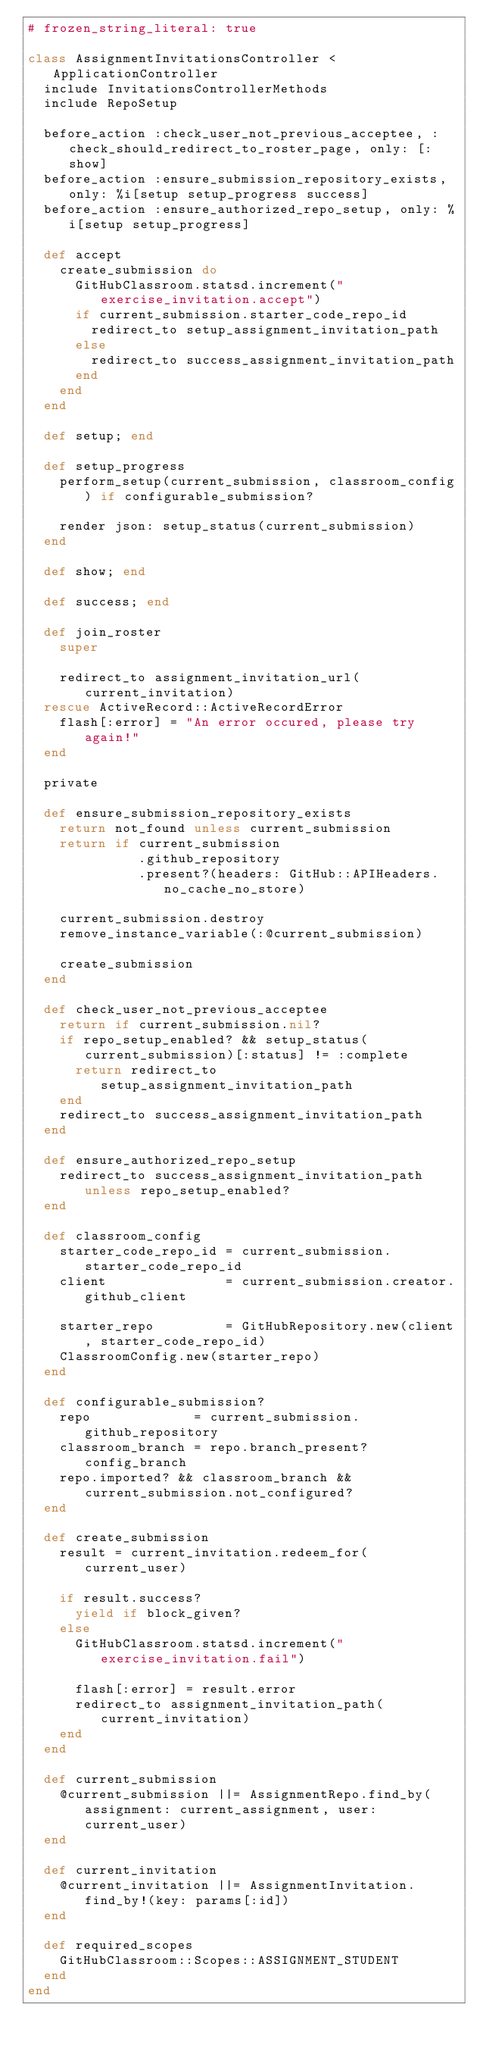Convert code to text. <code><loc_0><loc_0><loc_500><loc_500><_Ruby_># frozen_string_literal: true

class AssignmentInvitationsController < ApplicationController
  include InvitationsControllerMethods
  include RepoSetup

  before_action :check_user_not_previous_acceptee, :check_should_redirect_to_roster_page, only: [:show]
  before_action :ensure_submission_repository_exists, only: %i[setup setup_progress success]
  before_action :ensure_authorized_repo_setup, only: %i[setup setup_progress]

  def accept
    create_submission do
      GitHubClassroom.statsd.increment("exercise_invitation.accept")
      if current_submission.starter_code_repo_id
        redirect_to setup_assignment_invitation_path
      else
        redirect_to success_assignment_invitation_path
      end
    end
  end

  def setup; end

  def setup_progress
    perform_setup(current_submission, classroom_config) if configurable_submission?

    render json: setup_status(current_submission)
  end

  def show; end

  def success; end

  def join_roster
    super

    redirect_to assignment_invitation_url(current_invitation)
  rescue ActiveRecord::ActiveRecordError
    flash[:error] = "An error occured, please try again!"
  end

  private

  def ensure_submission_repository_exists
    return not_found unless current_submission
    return if current_submission
              .github_repository
              .present?(headers: GitHub::APIHeaders.no_cache_no_store)

    current_submission.destroy
    remove_instance_variable(:@current_submission)

    create_submission
  end

  def check_user_not_previous_acceptee
    return if current_submission.nil?
    if repo_setup_enabled? && setup_status(current_submission)[:status] != :complete
      return redirect_to setup_assignment_invitation_path
    end
    redirect_to success_assignment_invitation_path
  end

  def ensure_authorized_repo_setup
    redirect_to success_assignment_invitation_path unless repo_setup_enabled?
  end

  def classroom_config
    starter_code_repo_id = current_submission.starter_code_repo_id
    client               = current_submission.creator.github_client

    starter_repo         = GitHubRepository.new(client, starter_code_repo_id)
    ClassroomConfig.new(starter_repo)
  end

  def configurable_submission?
    repo             = current_submission.github_repository
    classroom_branch = repo.branch_present? config_branch
    repo.imported? && classroom_branch && current_submission.not_configured?
  end

  def create_submission
    result = current_invitation.redeem_for(current_user)

    if result.success?
      yield if block_given?
    else
      GitHubClassroom.statsd.increment("exercise_invitation.fail")

      flash[:error] = result.error
      redirect_to assignment_invitation_path(current_invitation)
    end
  end

  def current_submission
    @current_submission ||= AssignmentRepo.find_by(assignment: current_assignment, user: current_user)
  end

  def current_invitation
    @current_invitation ||= AssignmentInvitation.find_by!(key: params[:id])
  end

  def required_scopes
    GitHubClassroom::Scopes::ASSIGNMENT_STUDENT
  end
end
</code> 